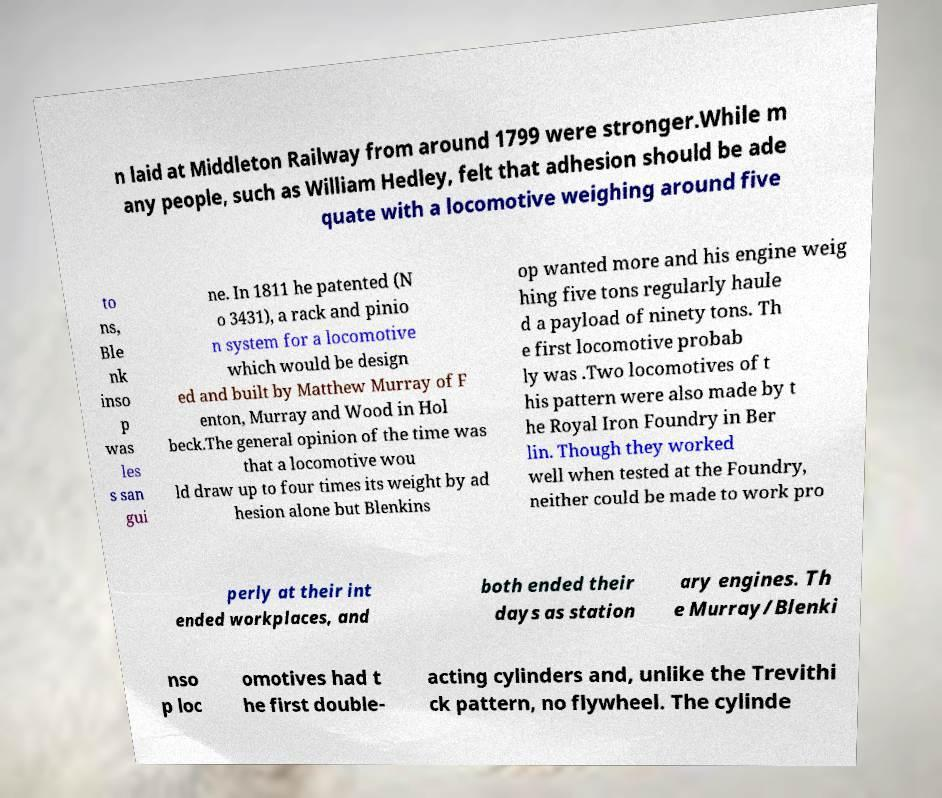Please read and relay the text visible in this image. What does it say? n laid at Middleton Railway from around 1799 were stronger.While m any people, such as William Hedley, felt that adhesion should be ade quate with a locomotive weighing around five to ns, Ble nk inso p was les s san gui ne. In 1811 he patented (N o 3431), a rack and pinio n system for a locomotive which would be design ed and built by Matthew Murray of F enton, Murray and Wood in Hol beck.The general opinion of the time was that a locomotive wou ld draw up to four times its weight by ad hesion alone but Blenkins op wanted more and his engine weig hing five tons regularly haule d a payload of ninety tons. Th e first locomotive probab ly was .Two locomotives of t his pattern were also made by t he Royal Iron Foundry in Ber lin. Though they worked well when tested at the Foundry, neither could be made to work pro perly at their int ended workplaces, and both ended their days as station ary engines. Th e Murray/Blenki nso p loc omotives had t he first double- acting cylinders and, unlike the Trevithi ck pattern, no flywheel. The cylinde 